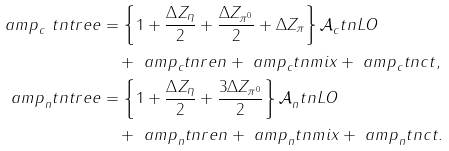<formula> <loc_0><loc_0><loc_500><loc_500>\ a m p _ { c } ^ { \ } t n { t r e e } & = \left \{ 1 + \frac { \Delta Z _ { \eta } } { 2 } + \frac { \Delta Z _ { \pi ^ { 0 } } } { 2 } + \Delta Z _ { \pi } \right \} \mathcal { A } _ { c } ^ { \ } t n { L O } \\ & \quad + \ a m p _ { c } ^ { \ } t n { r e n } + \ a m p _ { c } ^ { \ } t n { m i x } + \ a m p _ { c } ^ { \ } t n { c t } , \\ \ a m p _ { n } ^ { \ } t n { t r e e } & = \left \{ 1 + \frac { \Delta Z _ { \eta } } { 2 } + \frac { 3 \Delta Z _ { \pi ^ { 0 } } } { 2 } \right \} \mathcal { A } _ { n } ^ { \ } t n { L O } \\ & \quad + \ a m p _ { n } ^ { \ } t n { r e n } + \ a m p _ { n } ^ { \ } t n { m i x } + \ a m p _ { n } ^ { \ } t n { c t } .</formula> 